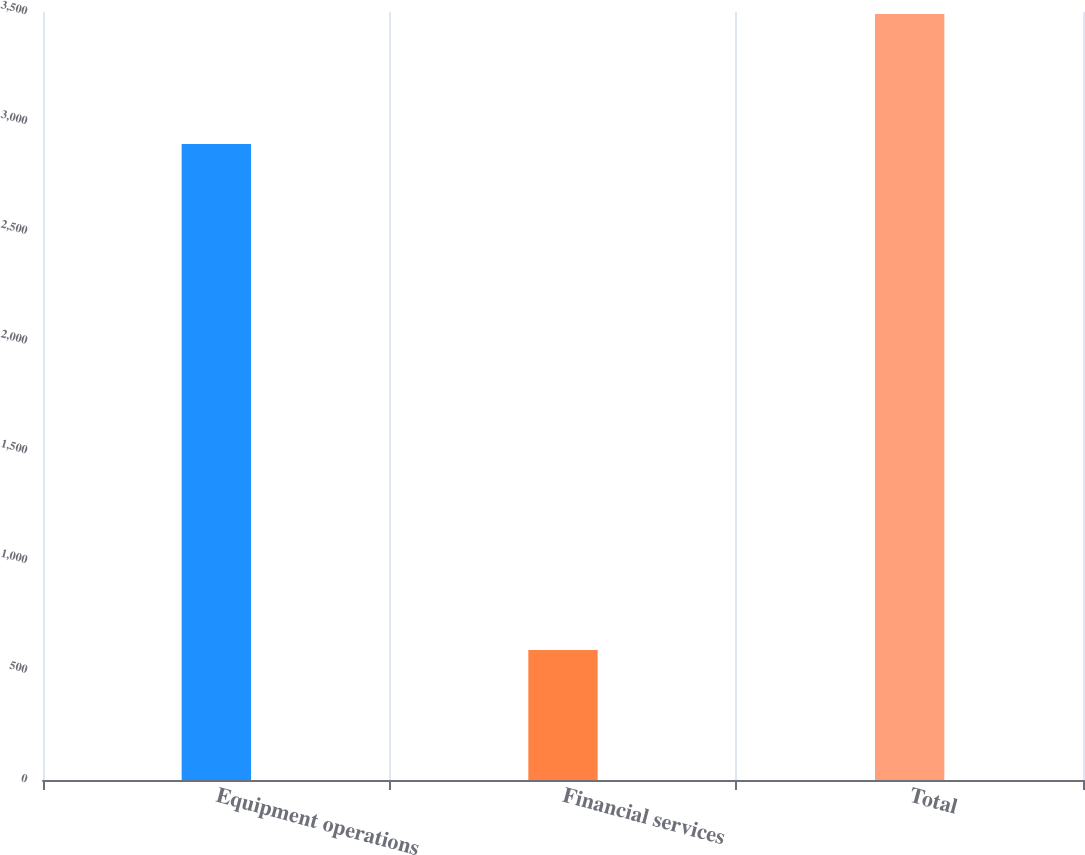Convert chart to OTSL. <chart><loc_0><loc_0><loc_500><loc_500><bar_chart><fcel>Equipment operations<fcel>Financial services<fcel>Total<nl><fcel>2898<fcel>593<fcel>3491<nl></chart> 